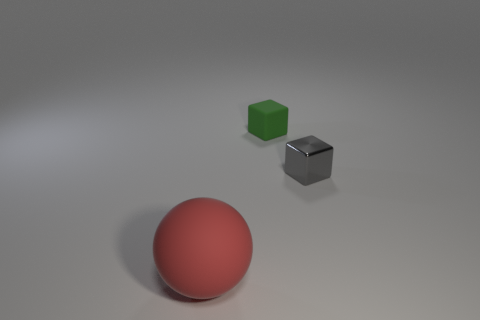Is the size of the matte sphere the same as the gray block?
Provide a succinct answer. No. Is the material of the tiny thing that is on the left side of the gray metallic object the same as the big red thing?
Your answer should be very brief. Yes. Are there any other things that have the same material as the large sphere?
Your answer should be very brief. Yes. There is a object that is in front of the tiny cube that is right of the tiny rubber block; how many matte objects are behind it?
Make the answer very short. 1. Is the shape of the rubber object that is behind the shiny object the same as  the tiny gray thing?
Offer a terse response. Yes. How many things are tiny gray metal objects or cubes that are behind the tiny metal object?
Your answer should be compact. 2. Is the number of small blocks in front of the tiny rubber object greater than the number of big cyan metallic things?
Give a very brief answer. Yes. Are there the same number of small green rubber cubes in front of the big red rubber sphere and blocks right of the tiny green matte cube?
Provide a short and direct response. No. Are there any rubber spheres behind the matte object behind the big red rubber thing?
Make the answer very short. No. What shape is the red object?
Give a very brief answer. Sphere. 